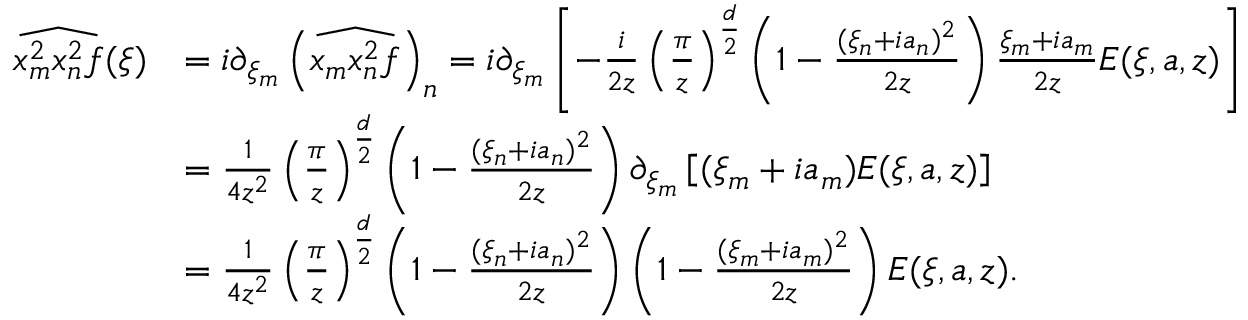<formula> <loc_0><loc_0><loc_500><loc_500>\begin{array} { r l } { \widehat { x _ { m } ^ { 2 } x _ { n } ^ { 2 } f } ( \xi ) } & { = i \partial _ { \xi _ { m } } \left ( \widehat { x _ { m } x _ { n } ^ { 2 } f } \right ) _ { n } = i \partial _ { \xi _ { m } } \left [ - \frac { i } { 2 z } \left ( \frac { \pi } { z } \right ) ^ { \frac { d } { 2 } } \left ( 1 - \frac { ( \xi _ { n } + i a _ { n } ) ^ { 2 } } { 2 z } \right ) \frac { \xi _ { m } + i a _ { m } } { 2 z } E ( \xi , a , z ) \right ] } \\ & { = \frac { 1 } { 4 z ^ { 2 } } \left ( \frac { \pi } { z } \right ) ^ { \frac { d } { 2 } } \left ( 1 - \frac { ( \xi _ { n } + i a _ { n } ) ^ { 2 } } { 2 z } \right ) \partial _ { \xi _ { m } } \left [ ( \xi _ { m } + i a _ { m } ) E ( \xi , a , z ) \right ] } \\ & { = \frac { 1 } { 4 z ^ { 2 } } \left ( \frac { \pi } { z } \right ) ^ { \frac { d } { 2 } } \left ( 1 - \frac { ( \xi _ { n } + i a _ { n } ) ^ { 2 } } { 2 z } \right ) \left ( 1 - \frac { ( \xi _ { m } + i a _ { m } ) ^ { 2 } } { 2 z } \right ) E ( \xi , a , z ) . } \end{array}</formula> 